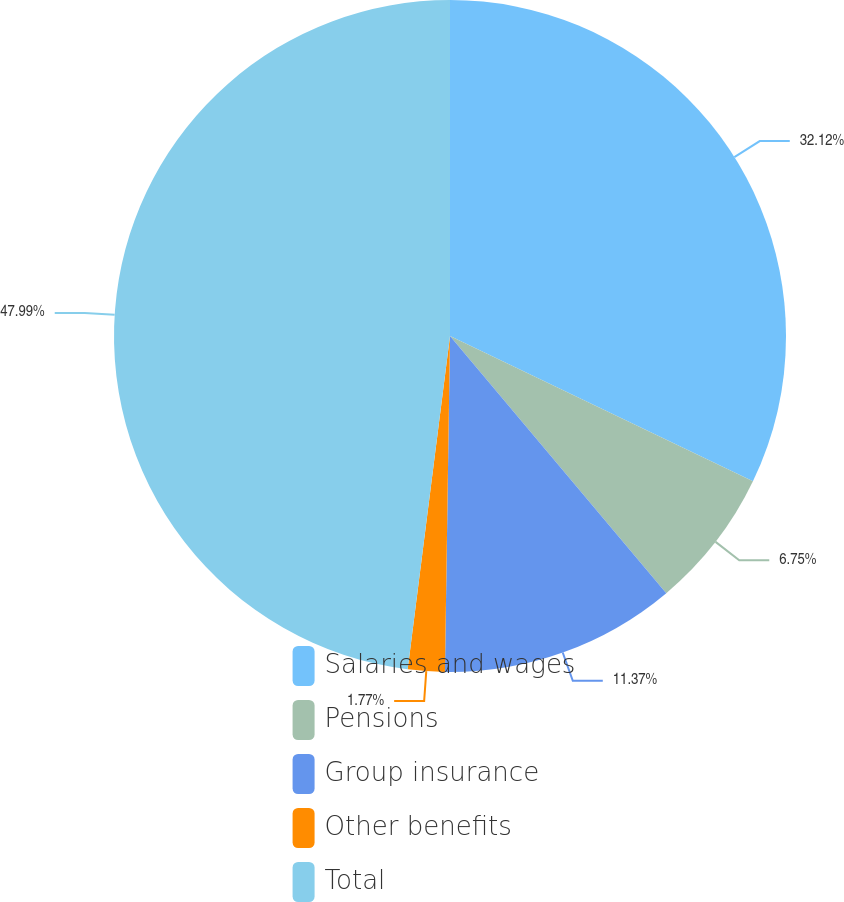<chart> <loc_0><loc_0><loc_500><loc_500><pie_chart><fcel>Salaries and wages<fcel>Pensions<fcel>Group insurance<fcel>Other benefits<fcel>Total<nl><fcel>32.12%<fcel>6.75%<fcel>11.37%<fcel>1.77%<fcel>47.99%<nl></chart> 